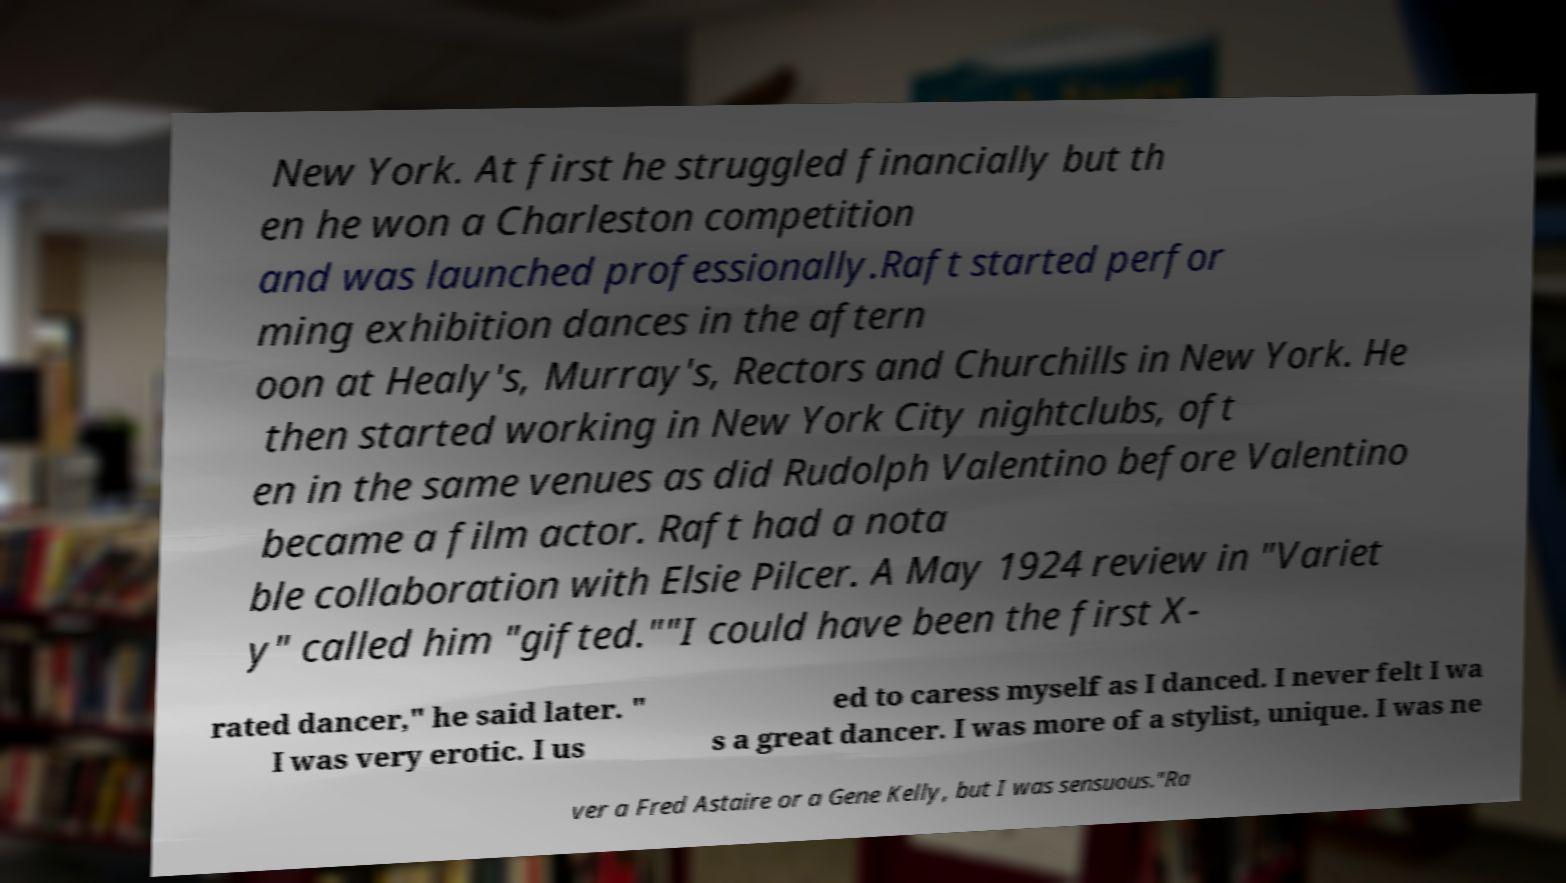Can you read and provide the text displayed in the image?This photo seems to have some interesting text. Can you extract and type it out for me? New York. At first he struggled financially but th en he won a Charleston competition and was launched professionally.Raft started perfor ming exhibition dances in the aftern oon at Healy's, Murray's, Rectors and Churchills in New York. He then started working in New York City nightclubs, oft en in the same venues as did Rudolph Valentino before Valentino became a film actor. Raft had a nota ble collaboration with Elsie Pilcer. A May 1924 review in "Variet y" called him "gifted.""I could have been the first X- rated dancer," he said later. " I was very erotic. I us ed to caress myself as I danced. I never felt I wa s a great dancer. I was more of a stylist, unique. I was ne ver a Fred Astaire or a Gene Kelly, but I was sensuous."Ra 